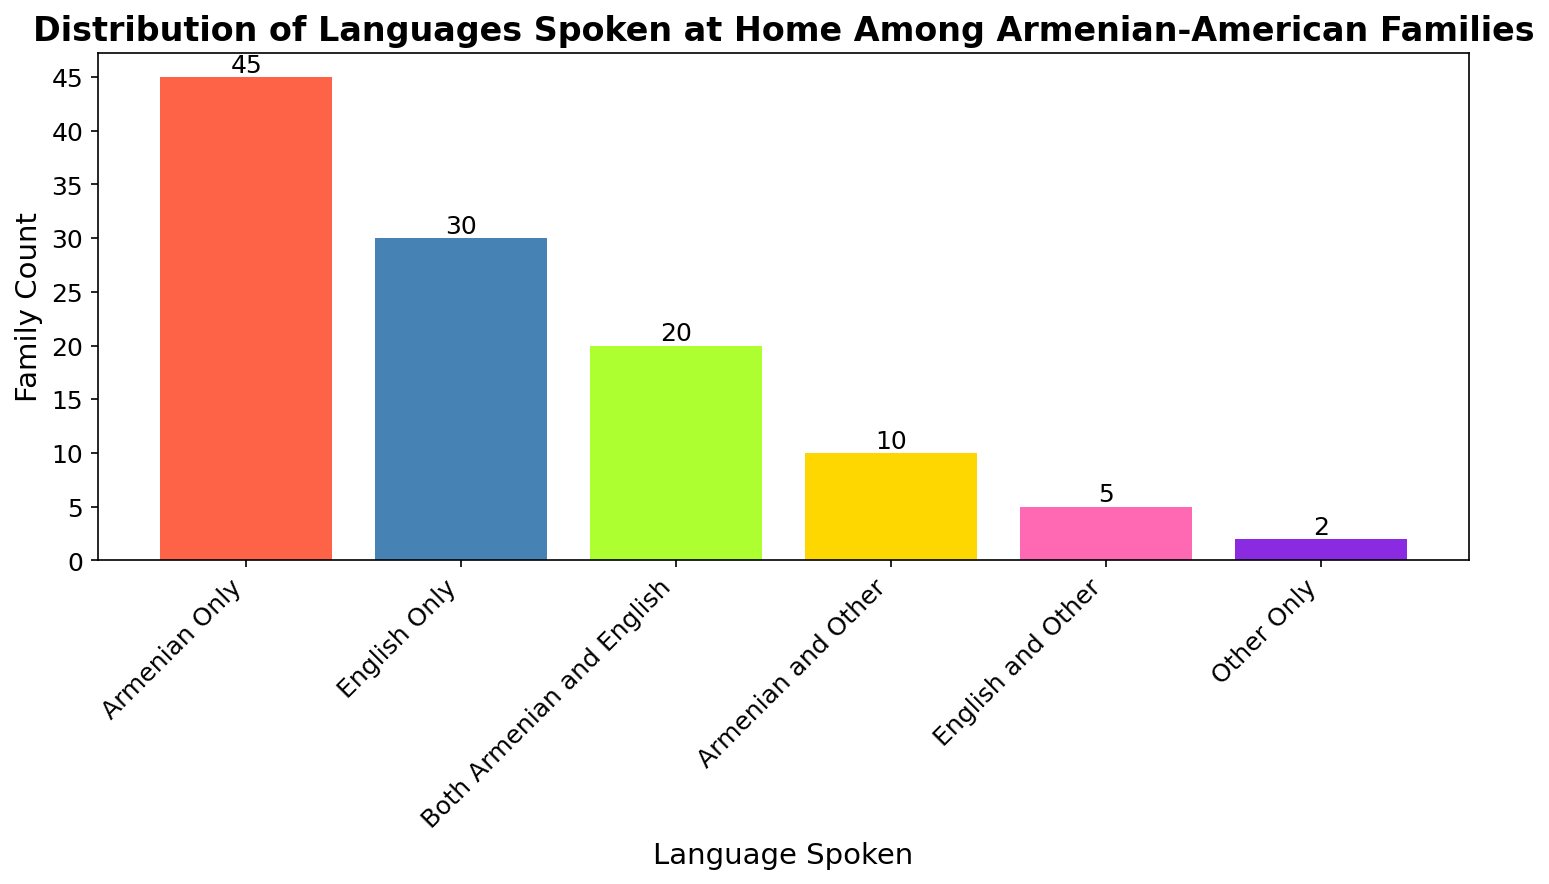What's the most common language spoken at home among Armenian-American families? The bar chart shows that "Armenian Only" has the highest count compared to other languages. By looking at the height of each bar, the "Armenian Only" bar is the tallest.
Answer: Armenian Only What's the total number of families that speak Armenian at home, either exclusively or with other languages? To find this, we sum up the counts of bars labeled "Armenian Only," "Both Armenian and English," and "Armenian and Other." The values are 45, 20, and 10, respectively. Adding these together: 45 + 20 + 10 = 75.
Answer: 75 How many more families speak Armenian Only compared to Both Armenian and English? We need to find the difference between the counts of "Armenian Only" and "Both Armenian and English." The counts are 45 and 20, respectively. Therefore: 45 - 20 = 25.
Answer: 25 Which language category has the fewest families, and how many families fall into this category? By examining the height of each bar, "Other Only" is the shortest. The count for "Other Only" is 2.
Answer: Other Only, 2 What's the combined count of families speaking only one language at home? We sum the counts of "Armenian Only," "English Only," and "Other Only." The values are 45, 30, and 2, respectively. Adding these together: 45 + 30 + 2 = 77.
Answer: 77 Which language(s) is/are spoken by a total of more than 50 families? By referring to the bar heights, "Armenian Only" exceeds 50 families, with a count of 45. No individual category other surpasses 50, but just checking the highest, "Armenian Only."
Answer: None Are there more families that speak English only or Both Armenian and English? Compare the heights of bars "English Only" and "Both Armenian and English." The counts are 30 and 20, respectively. Since 30 > 20, there are more families speaking "English Only."
Answer: English Only What is the difference between the counts of families speaking English Only and Armenian and Other? The counts for "English Only" and "Armenian and Other" are 30 and 10, respectively. Hence: 30 - 10 = 20.
Answer: 20 How many families speak more than one language at home? We need to sum the counts for "Both Armenian and English," "Armenian and Other," and "English and Other." The values are 20, 10, and 5, respectively. So, 20 + 10 + 5 = 35.
Answer: 35 What are the exact count values represented by the colors red and blue, respectively? By identifying the color of the bars, "Armenian Only" is red and "English Only" is blue. Their counts are 45 and 30, respectively.
Answer: Red: 45, Blue: 30 